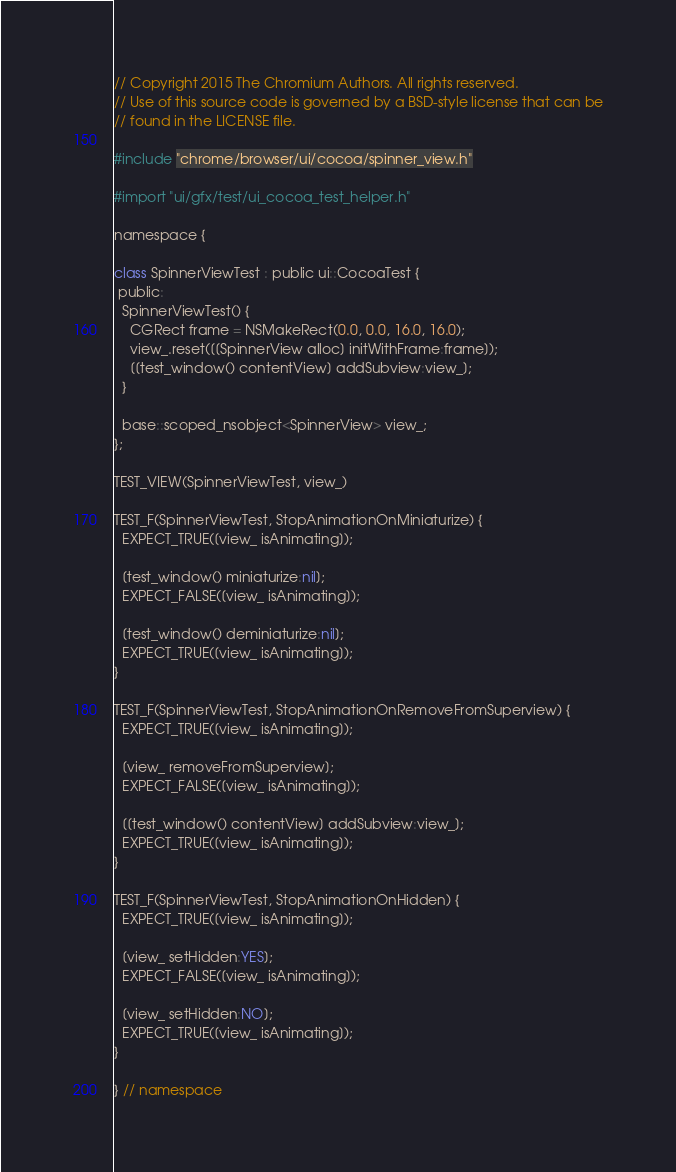<code> <loc_0><loc_0><loc_500><loc_500><_ObjectiveC_>// Copyright 2015 The Chromium Authors. All rights reserved.
// Use of this source code is governed by a BSD-style license that can be
// found in the LICENSE file.

#include "chrome/browser/ui/cocoa/spinner_view.h"

#import "ui/gfx/test/ui_cocoa_test_helper.h"

namespace {

class SpinnerViewTest : public ui::CocoaTest {
 public:
  SpinnerViewTest() {
    CGRect frame = NSMakeRect(0.0, 0.0, 16.0, 16.0);
    view_.reset([[SpinnerView alloc] initWithFrame:frame]);
    [[test_window() contentView] addSubview:view_];
  }

  base::scoped_nsobject<SpinnerView> view_;
};

TEST_VIEW(SpinnerViewTest, view_)

TEST_F(SpinnerViewTest, StopAnimationOnMiniaturize) {
  EXPECT_TRUE([view_ isAnimating]);

  [test_window() miniaturize:nil];
  EXPECT_FALSE([view_ isAnimating]);

  [test_window() deminiaturize:nil];
  EXPECT_TRUE([view_ isAnimating]);
}

TEST_F(SpinnerViewTest, StopAnimationOnRemoveFromSuperview) {
  EXPECT_TRUE([view_ isAnimating]);

  [view_ removeFromSuperview];
  EXPECT_FALSE([view_ isAnimating]);

  [[test_window() contentView] addSubview:view_];
  EXPECT_TRUE([view_ isAnimating]);
}

TEST_F(SpinnerViewTest, StopAnimationOnHidden) {
  EXPECT_TRUE([view_ isAnimating]);

  [view_ setHidden:YES];
  EXPECT_FALSE([view_ isAnimating]);

  [view_ setHidden:NO];
  EXPECT_TRUE([view_ isAnimating]);
}

} // namespace
</code> 